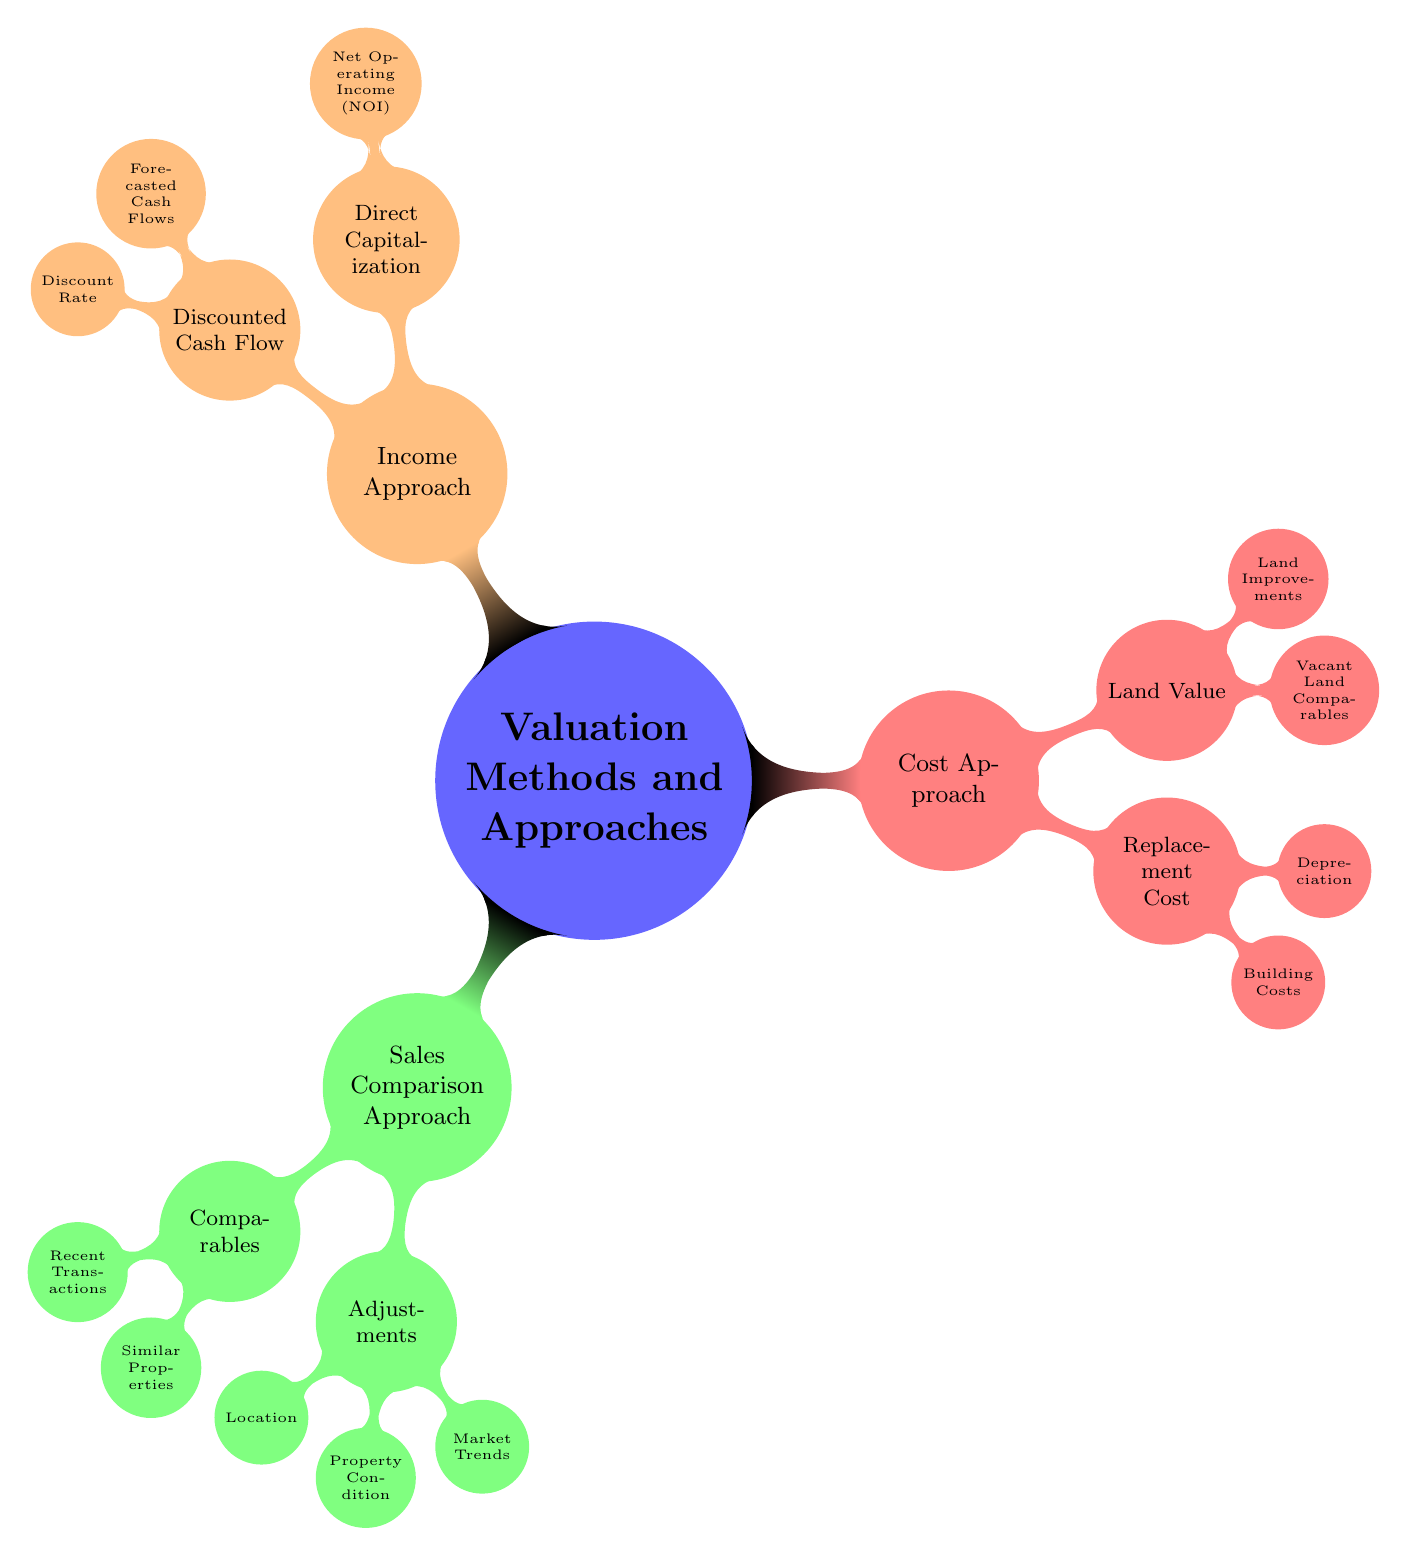What are the three primary valuation approaches included in the diagram? The central topic of the diagram is "Valuation Methods and Approaches," which branches out into three primary nodes: Sales Comparison Approach, Cost Approach, and Income Approach.
Answer: Sales Comparison Approach, Cost Approach, Income Approach How many adjustments are listed under the Sales Comparison Approach? Under the Sales Comparison Approach, there are three adjustments mentioned: Location, Property Condition, and Market Trends, indicating the number of relevant factors that affect the valuation using this method.
Answer: Three What is the subcategory listed under Replacement Cost in the Cost Approach? Replacement Cost in the Cost Approach consists of two subcategories: Building Costs and Depreciation. To identify the subcategory, we look at the child nodes under Replacement Cost in the diagram.
Answer: Building Costs, Depreciation What components make up the Net Operating Income (NOI) in the Income Approach? The Income Approach node Direct Capitalization branches out to the Net Operating Income (NOI), which is further detailed by three components: Gross Potential Rent, Vacancy & Collection Loss, and Operating Expenses, showing the breakdown of NOI calculations.
Answer: Gross Potential Rent, Vacancy & Collection Loss, Operating Expenses What is a factor that affects Depreciation in the Cost Approach? The Depreciation node under the Cost Approach includes two specific factors: Physical Depreciation and Functional Obsolescence. To identify a factor affecting Depreciation, we can refer to these sub-nodes directly.
Answer: Physical Depreciation, Functional Obsolescence How many nodes are children of the Income Approach? The Income Approach has two main child nodes: Direct Capitalization and Discounted Cash Flow, indicating that there are two distinct methods of income assessment in this approach.
Answer: Two 